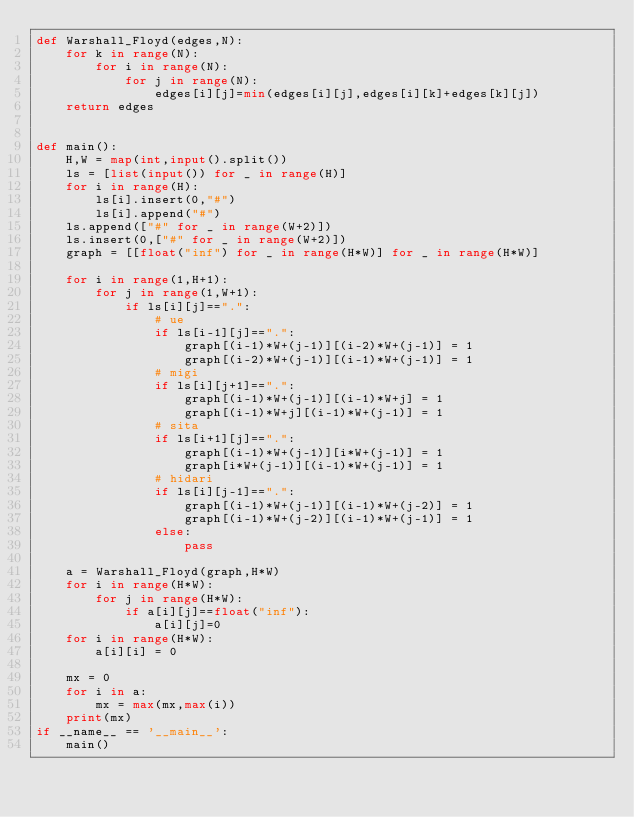<code> <loc_0><loc_0><loc_500><loc_500><_Python_>def Warshall_Floyd(edges,N):
    for k in range(N):
        for i in range(N):
            for j in range(N):
                edges[i][j]=min(edges[i][j],edges[i][k]+edges[k][j])
    return edges


def main():
    H,W = map(int,input().split())
    ls = [list(input()) for _ in range(H)]
    for i in range(H):
        ls[i].insert(0,"#")
        ls[i].append("#")
    ls.append(["#" for _ in range(W+2)])
    ls.insert(0,["#" for _ in range(W+2)])
    graph = [[float("inf") for _ in range(H*W)] for _ in range(H*W)]

    for i in range(1,H+1):
        for j in range(1,W+1):
            if ls[i][j]==".":
                # ue
                if ls[i-1][j]==".":
                    graph[(i-1)*W+(j-1)][(i-2)*W+(j-1)] = 1
                    graph[(i-2)*W+(j-1)][(i-1)*W+(j-1)] = 1
                # migi
                if ls[i][j+1]==".":
                    graph[(i-1)*W+(j-1)][(i-1)*W+j] = 1
                    graph[(i-1)*W+j][(i-1)*W+(j-1)] = 1
                # sita
                if ls[i+1][j]==".":
                    graph[(i-1)*W+(j-1)][i*W+(j-1)] = 1
                    graph[i*W+(j-1)][(i-1)*W+(j-1)] = 1
                # hidari
                if ls[i][j-1]==".":
                    graph[(i-1)*W+(j-1)][(i-1)*W+(j-2)] = 1
                    graph[(i-1)*W+(j-2)][(i-1)*W+(j-1)] = 1
                else:
                    pass

    a = Warshall_Floyd(graph,H*W)
    for i in range(H*W):
        for j in range(H*W):
            if a[i][j]==float("inf"):
                a[i][j]=0
    for i in range(H*W):
        a[i][i] = 0

    mx = 0
    for i in a:
        mx = max(mx,max(i))
    print(mx)
if __name__ == '__main__':
    main()</code> 